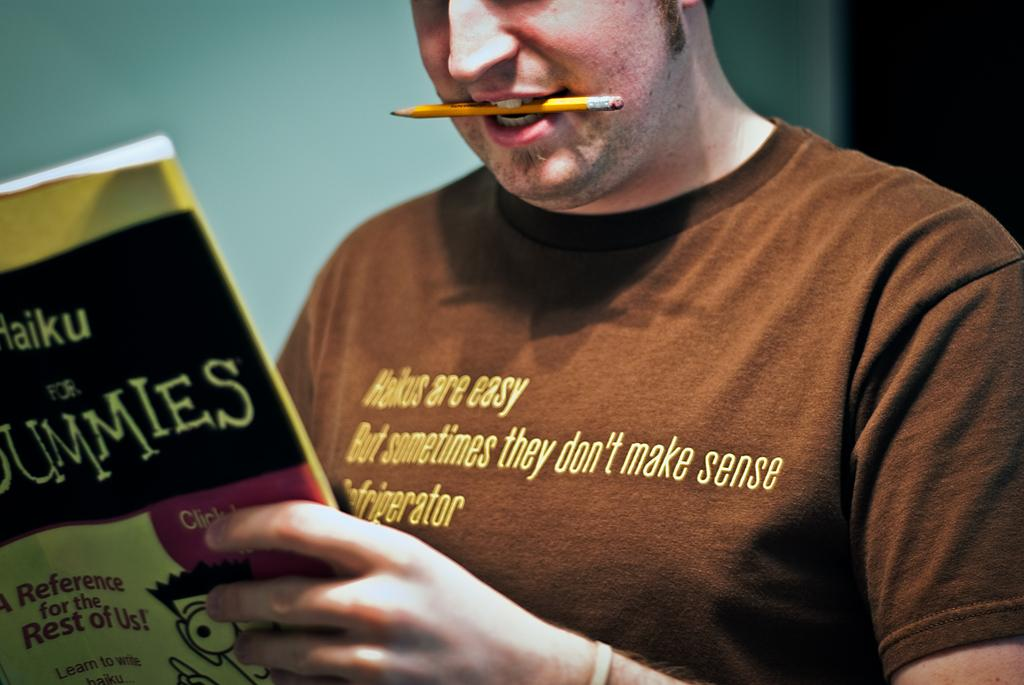<image>
Summarize the visual content of the image. A man with a pencil in his mouth reading haiku for dummies. 